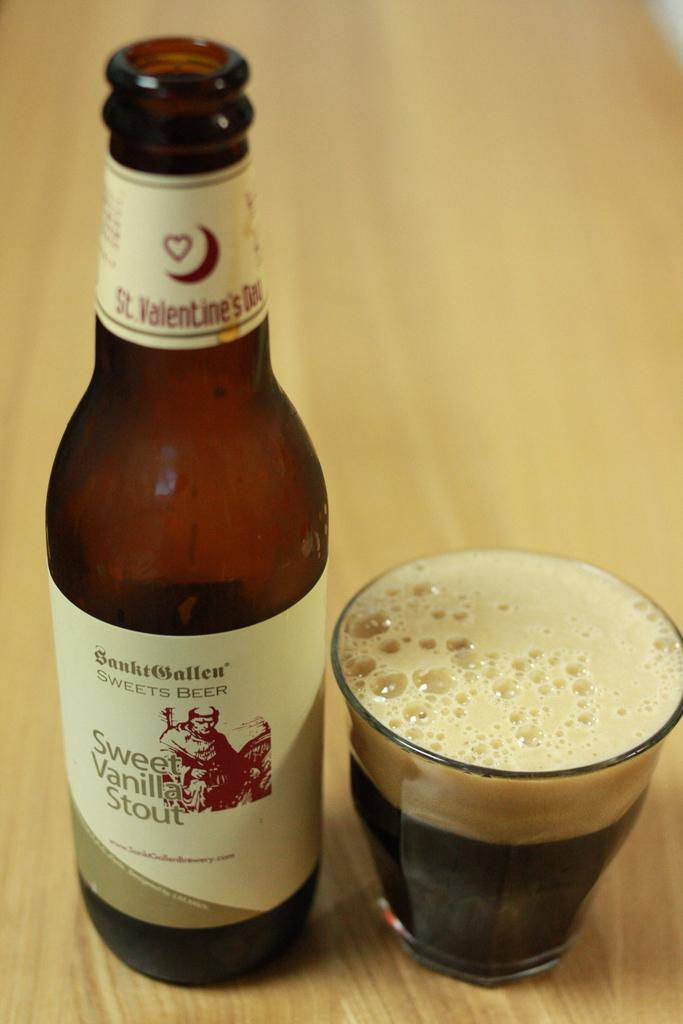<image>
Describe the image concisely. A Sweet Vanilla Stout beer sits on a wooden table alongside a glass filled with very dark beer to the brim with foam on top. 